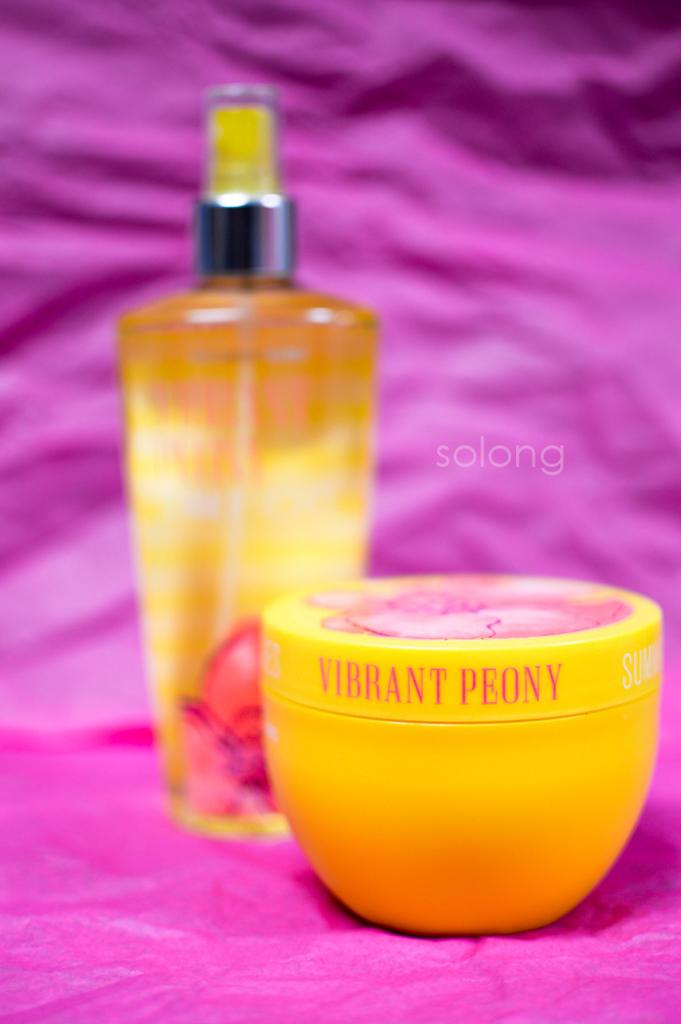<image>
Share a concise interpretation of the image provided. Vibrant Peony mist and lotion being displayed on top of a pink backdrop. 